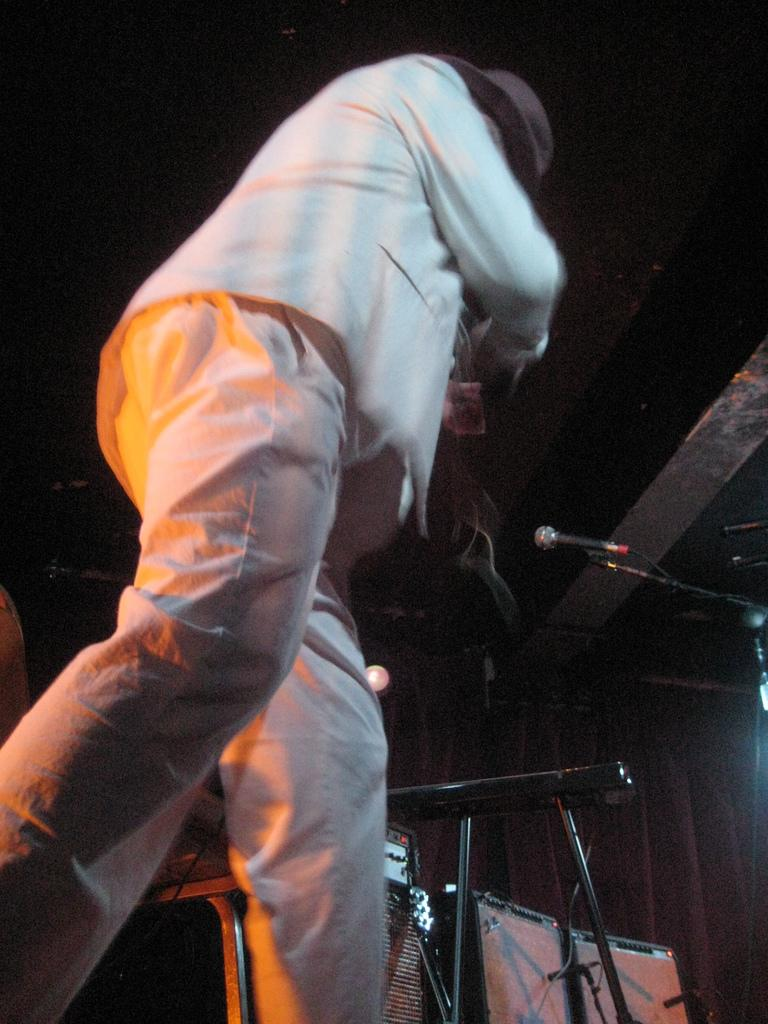What is the main subject of the image? The main subject of the image is a man. What is the man doing in the image? The man is standing and holding a musical instrument. What objects are present in the image that are related to music? There are microphones and musical devices in the image. What flavor of ice cream is the servant offering to the authority in the image? There is no ice cream, servant, or authority present in the image. 